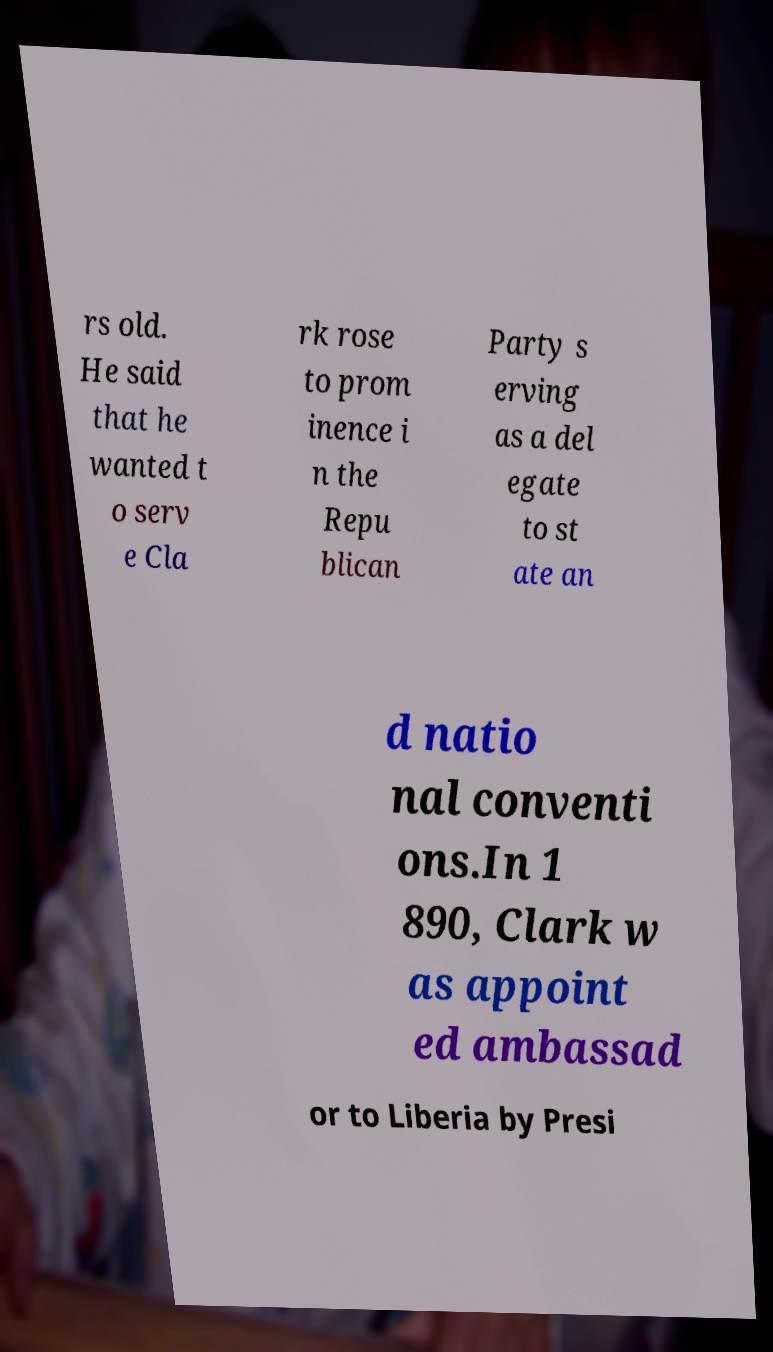For documentation purposes, I need the text within this image transcribed. Could you provide that? rs old. He said that he wanted t o serv e Cla rk rose to prom inence i n the Repu blican Party s erving as a del egate to st ate an d natio nal conventi ons.In 1 890, Clark w as appoint ed ambassad or to Liberia by Presi 